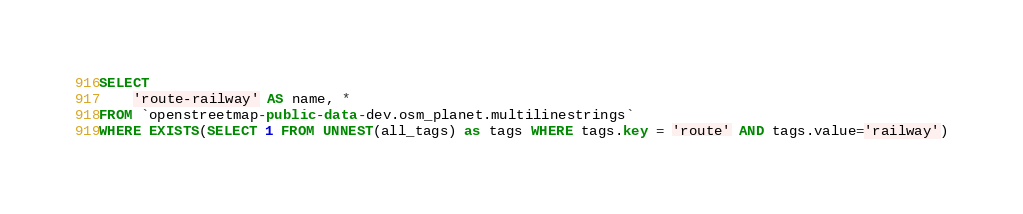Convert code to text. <code><loc_0><loc_0><loc_500><loc_500><_SQL_>SELECT
    'route-railway' AS name, *
FROM `openstreetmap-public-data-dev.osm_planet.multilinestrings`
WHERE EXISTS(SELECT 1 FROM UNNEST(all_tags) as tags WHERE tags.key = 'route' AND tags.value='railway')
</code> 